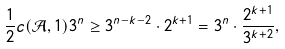Convert formula to latex. <formula><loc_0><loc_0><loc_500><loc_500>\frac { 1 } { 2 } c ( \mathcal { A } , 1 ) 3 ^ { n } \geq 3 ^ { n - k - 2 } \cdot 2 ^ { k + 1 } = 3 ^ { n } \cdot \frac { 2 ^ { k + 1 } } { 3 ^ { k + 2 } } ,</formula> 